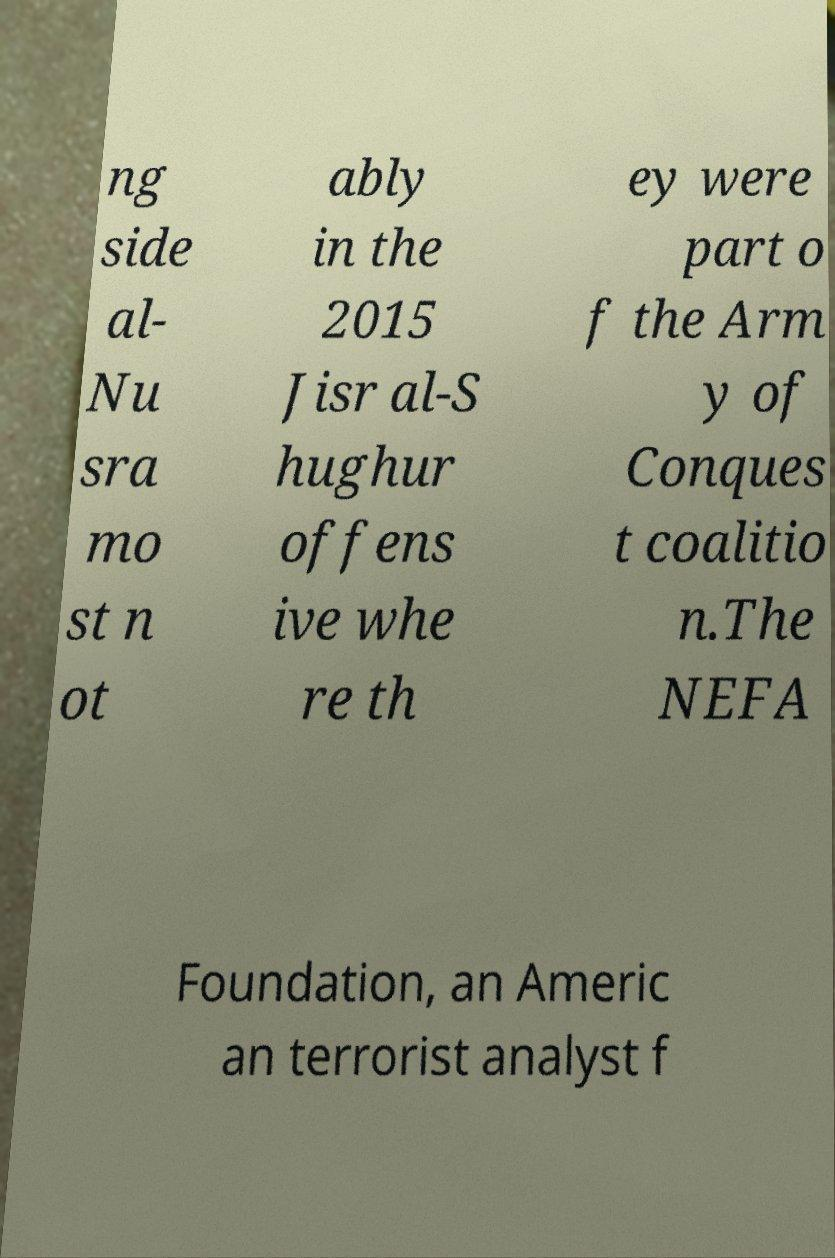There's text embedded in this image that I need extracted. Can you transcribe it verbatim? ng side al- Nu sra mo st n ot ably in the 2015 Jisr al-S hughur offens ive whe re th ey were part o f the Arm y of Conques t coalitio n.The NEFA Foundation, an Americ an terrorist analyst f 